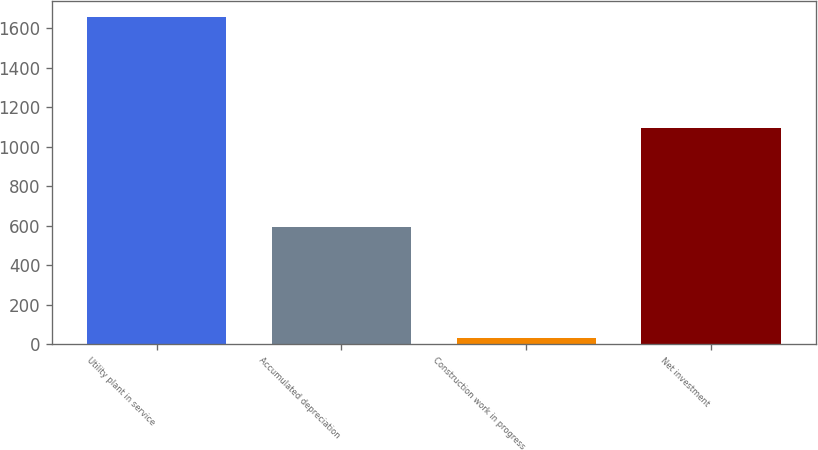Convert chart to OTSL. <chart><loc_0><loc_0><loc_500><loc_500><bar_chart><fcel>Utility plant in service<fcel>Accumulated depreciation<fcel>Construction work in progress<fcel>Net investment<nl><fcel>1655<fcel>592<fcel>30<fcel>1093<nl></chart> 